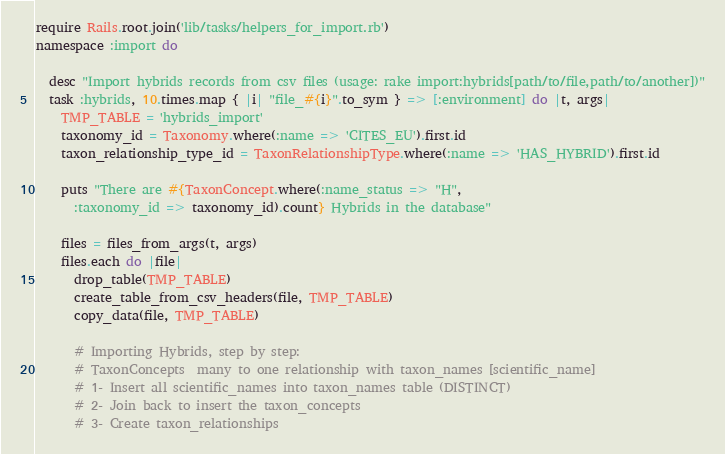Convert code to text. <code><loc_0><loc_0><loc_500><loc_500><_Ruby_>require Rails.root.join('lib/tasks/helpers_for_import.rb')
namespace :import do

  desc "Import hybrids records from csv files (usage: rake import:hybrids[path/to/file,path/to/another])"
  task :hybrids, 10.times.map { |i| "file_#{i}".to_sym } => [:environment] do |t, args|
    TMP_TABLE = 'hybrids_import'
    taxonomy_id = Taxonomy.where(:name => 'CITES_EU').first.id
    taxon_relationship_type_id = TaxonRelationshipType.where(:name => 'HAS_HYBRID').first.id

    puts "There are #{TaxonConcept.where(:name_status => "H",
      :taxonomy_id => taxonomy_id).count} Hybrids in the database"

    files = files_from_args(t, args)
    files.each do |file|
      drop_table(TMP_TABLE)
      create_table_from_csv_headers(file, TMP_TABLE)
      copy_data(file, TMP_TABLE)

      # Importing Hybrids, step by step:
      # TaxonConcepts  many to one relationship with taxon_names [scientific_name]
      # 1- Insert all scientific_names into taxon_names table (DISTINCT)
      # 2- Join back to insert the taxon_concepts
      # 3- Create taxon_relationships</code> 